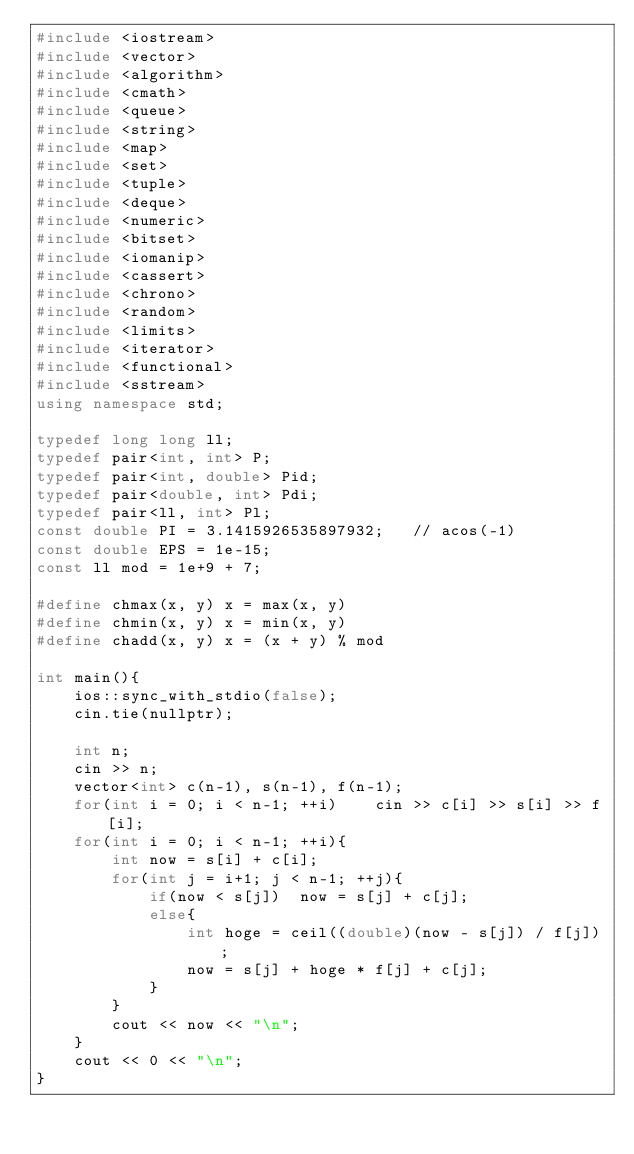<code> <loc_0><loc_0><loc_500><loc_500><_C++_>#include <iostream>
#include <vector>
#include <algorithm>
#include <cmath>
#include <queue>
#include <string>
#include <map>
#include <set>
#include <tuple>
#include <deque>
#include <numeric>
#include <bitset>
#include <iomanip>
#include <cassert>
#include <chrono>
#include <random>
#include <limits>
#include <iterator>
#include <functional>
#include <sstream>
using namespace std;

typedef long long ll;
typedef pair<int, int> P;
typedef pair<int, double> Pid;
typedef pair<double, int> Pdi;
typedef pair<ll, int> Pl;
const double PI = 3.1415926535897932;   // acos(-1)
const double EPS = 1e-15;
const ll mod = 1e+9 + 7;

#define chmax(x, y) x = max(x, y)
#define chmin(x, y) x = min(x, y)
#define chadd(x, y) x = (x + y) % mod

int main(){
    ios::sync_with_stdio(false);
    cin.tie(nullptr);

    int n;
    cin >> n;
    vector<int> c(n-1), s(n-1), f(n-1);
    for(int i = 0; i < n-1; ++i)    cin >> c[i] >> s[i] >> f[i];
    for(int i = 0; i < n-1; ++i){
        int now = s[i] + c[i];
        for(int j = i+1; j < n-1; ++j){
            if(now < s[j])  now = s[j] + c[j];
            else{
                int hoge = ceil((double)(now - s[j]) / f[j]);
                now = s[j] + hoge * f[j] + c[j];
            }
        }
        cout << now << "\n";
    }
    cout << 0 << "\n";
}</code> 